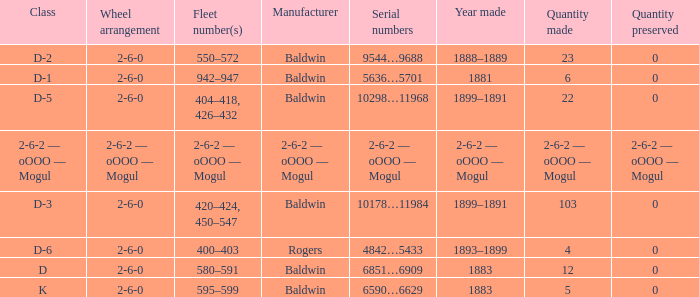What is the quantity made when the class is d-2? 23.0. 